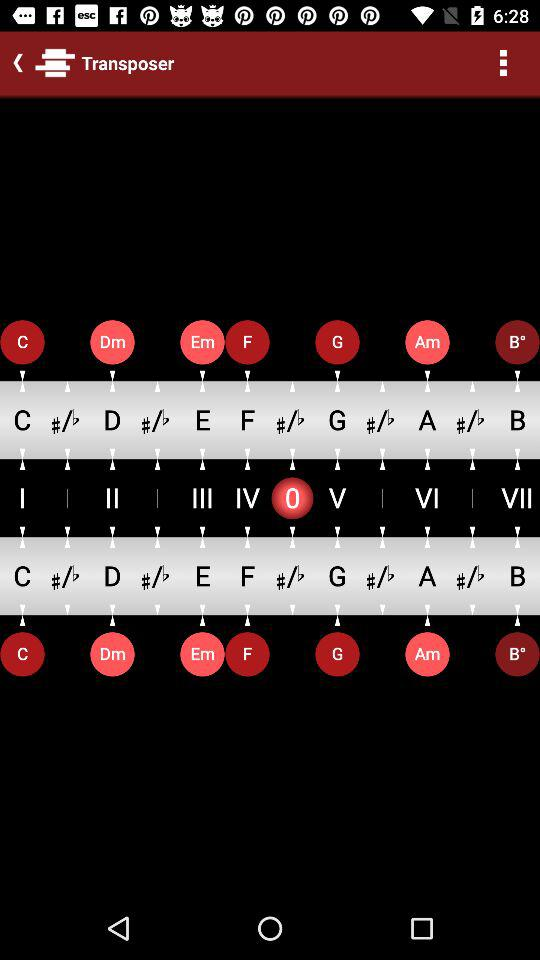What is the application name? The application name is "Transposer". 